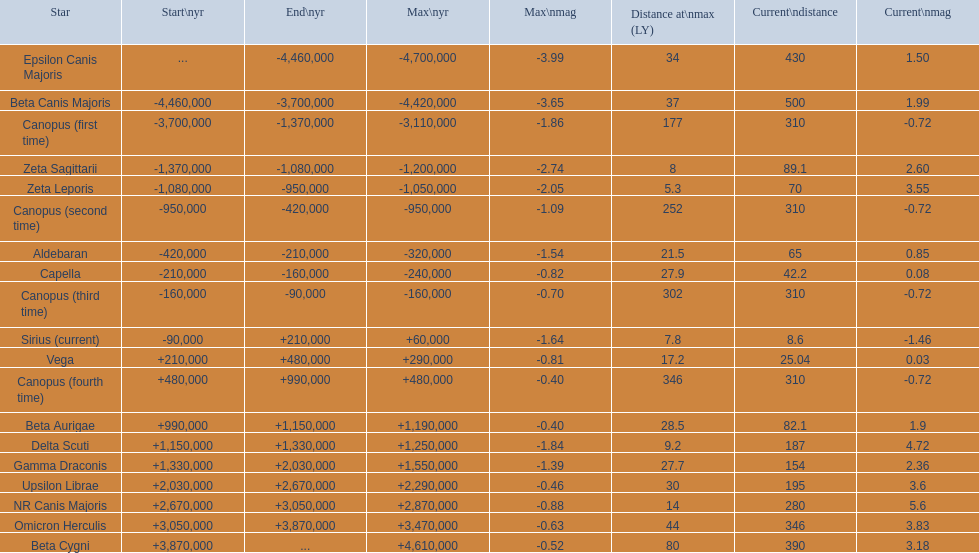What star has a a maximum magnitude of -0.63. Omicron Herculis. What star has a current distance of 390? Beta Cygni. 